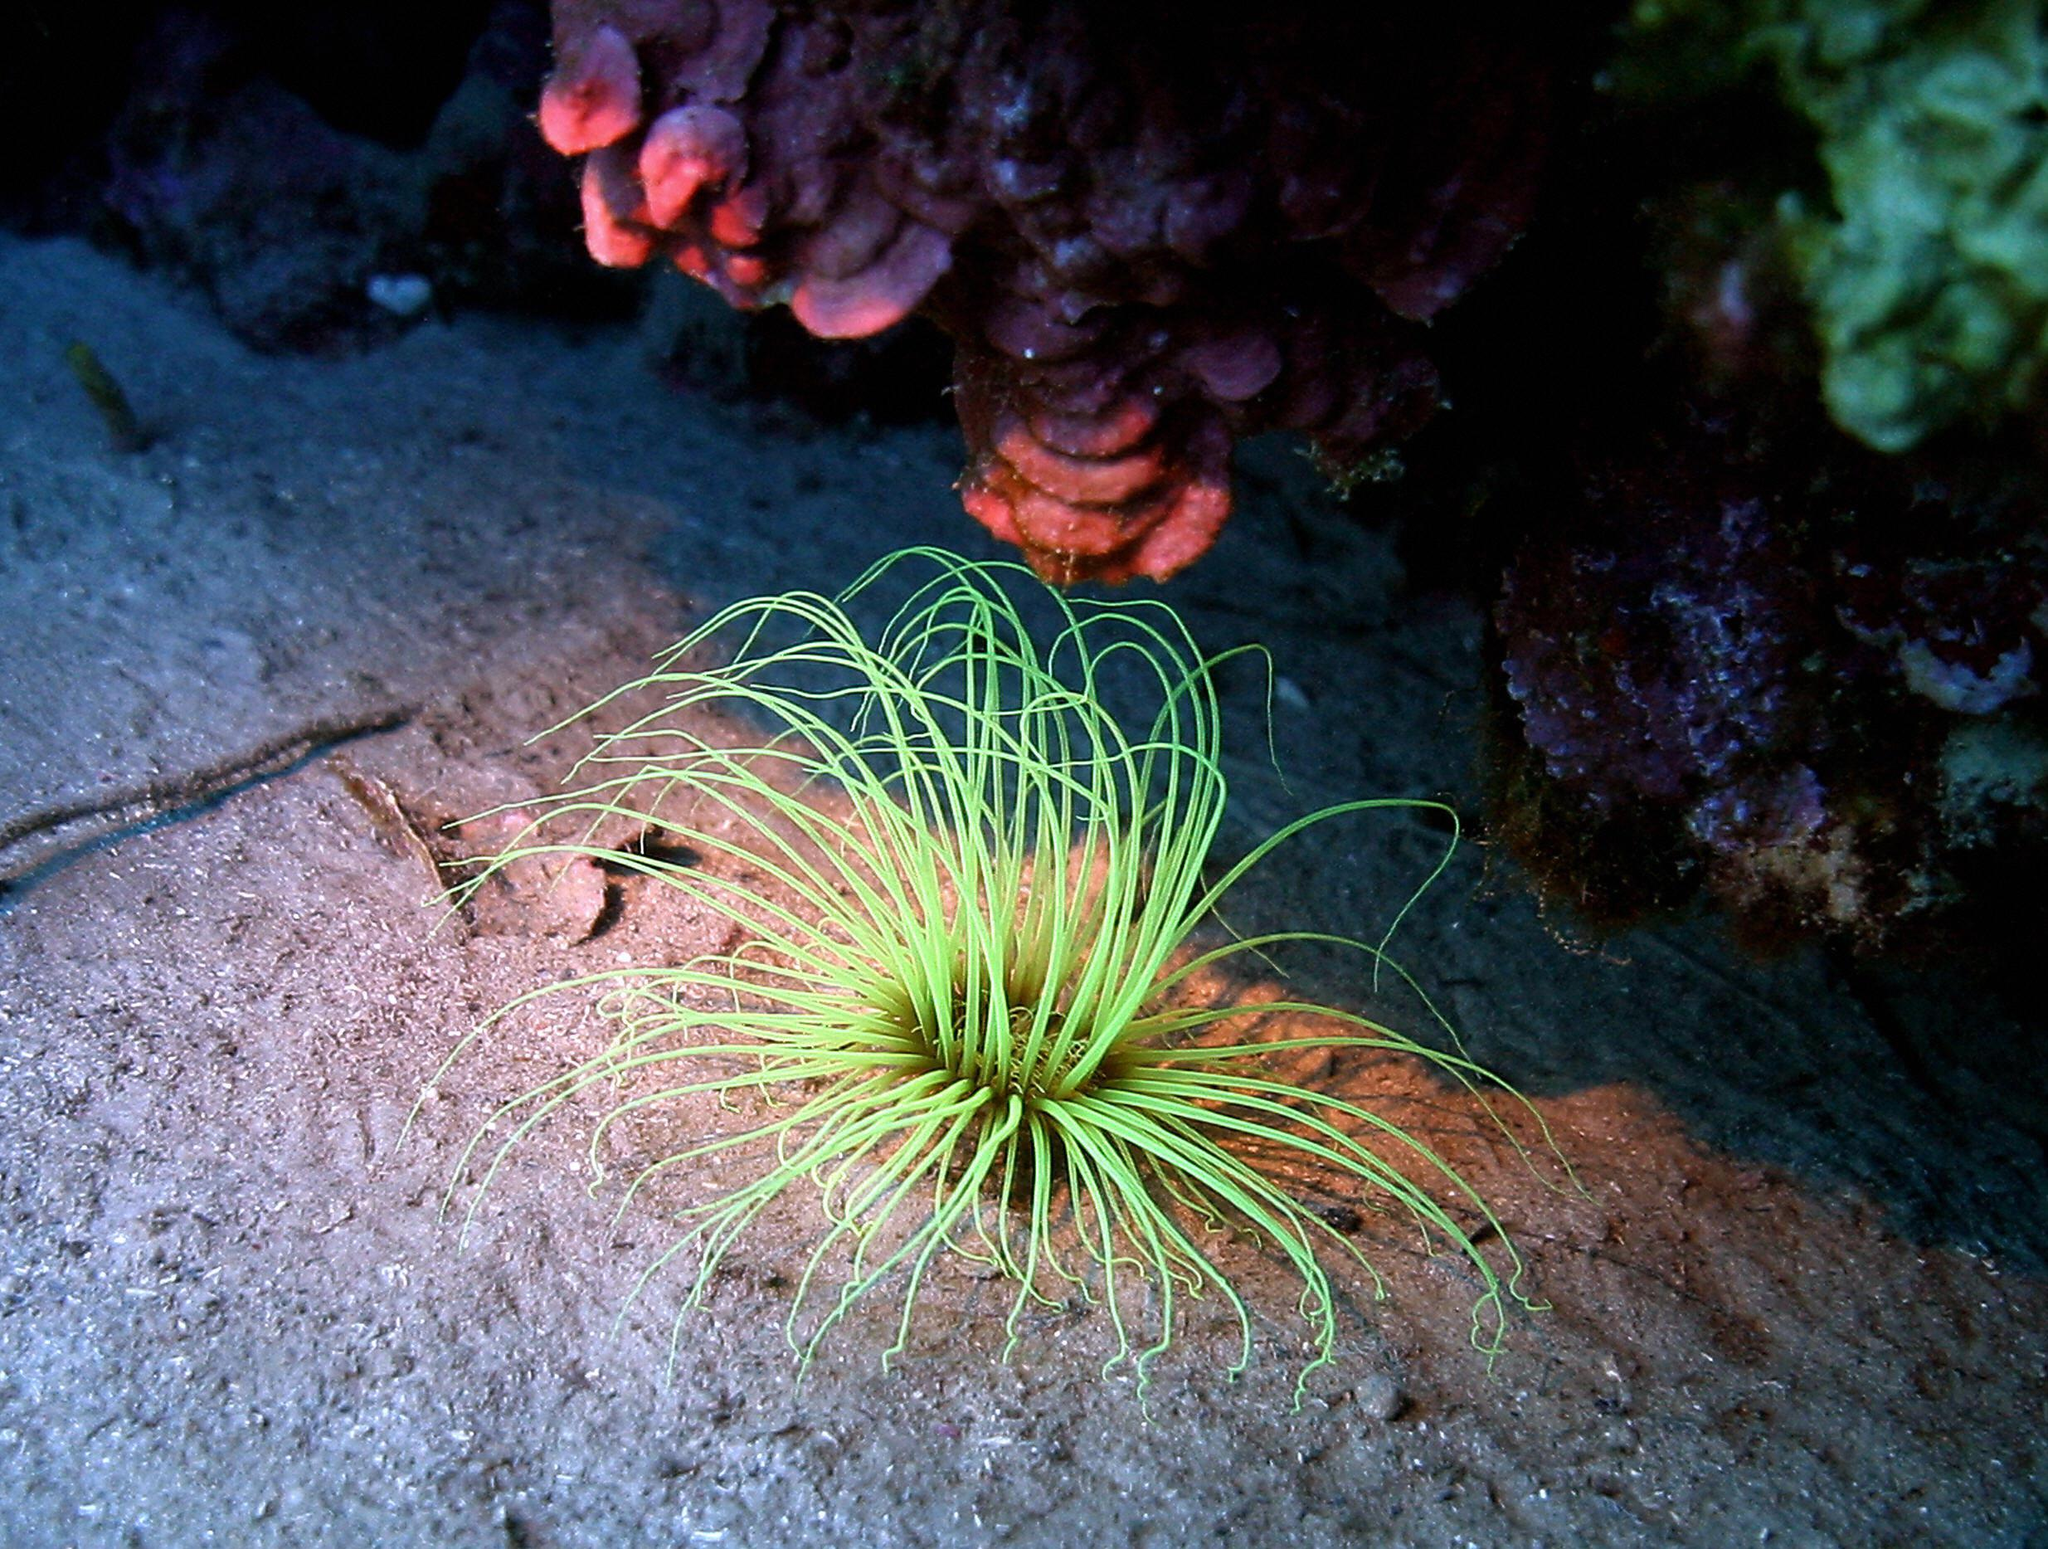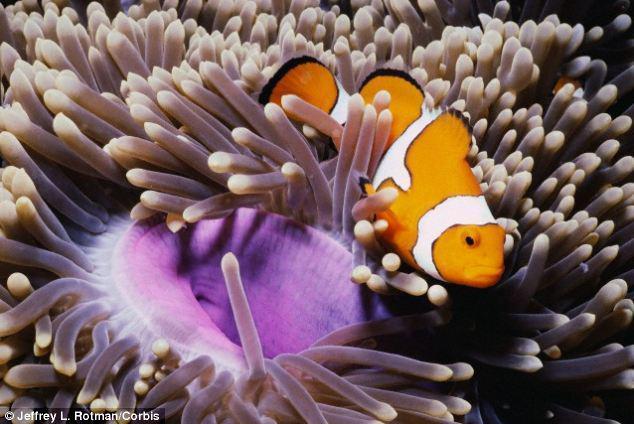The first image is the image on the left, the second image is the image on the right. For the images displayed, is the sentence "Right image features at least one anemone with a green tint." factually correct? Answer yes or no. No. 